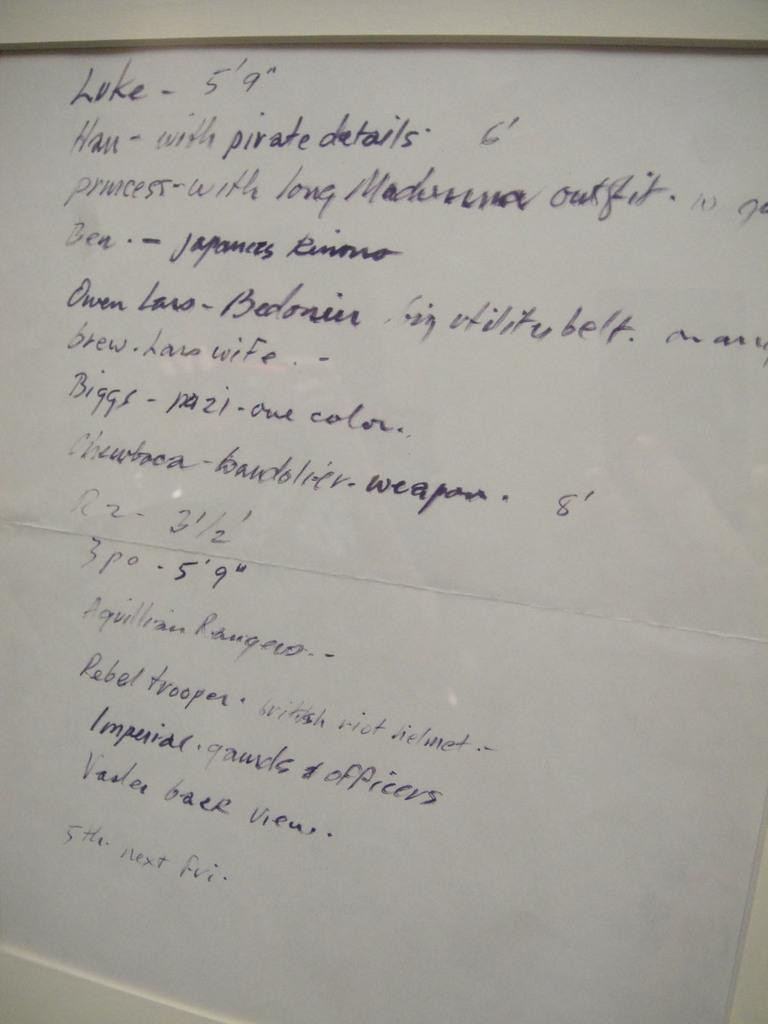<image>
Write a terse but informative summary of the picture. "Luke - 5'9"" is written at the top of a white board. 